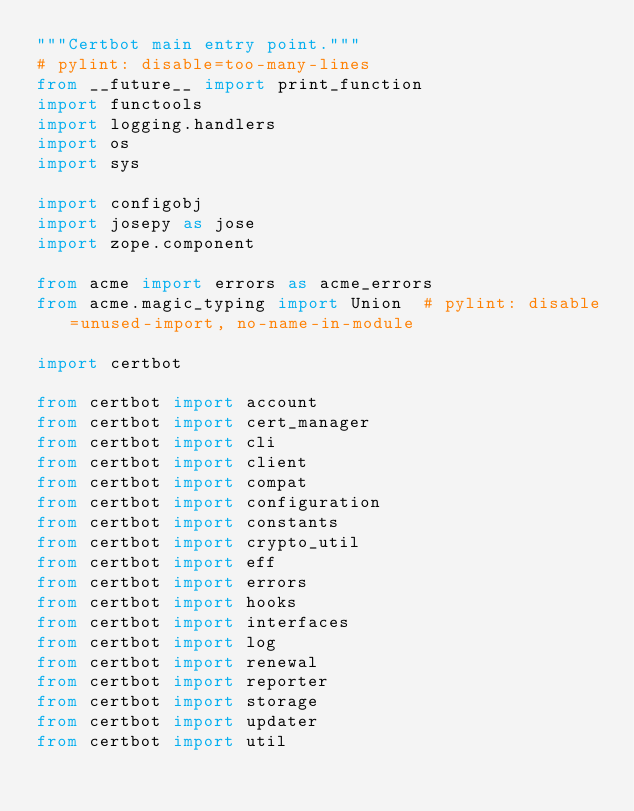Convert code to text. <code><loc_0><loc_0><loc_500><loc_500><_Python_>"""Certbot main entry point."""
# pylint: disable=too-many-lines
from __future__ import print_function
import functools
import logging.handlers
import os
import sys

import configobj
import josepy as jose
import zope.component

from acme import errors as acme_errors
from acme.magic_typing import Union  # pylint: disable=unused-import, no-name-in-module

import certbot

from certbot import account
from certbot import cert_manager
from certbot import cli
from certbot import client
from certbot import compat
from certbot import configuration
from certbot import constants
from certbot import crypto_util
from certbot import eff
from certbot import errors
from certbot import hooks
from certbot import interfaces
from certbot import log
from certbot import renewal
from certbot import reporter
from certbot import storage
from certbot import updater
from certbot import util
</code> 